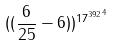Convert formula to latex. <formula><loc_0><loc_0><loc_500><loc_500>( ( \frac { 6 } { 2 5 } - 6 ) ) ^ { { 1 7 ^ { 3 9 2 } } ^ { 4 } }</formula> 